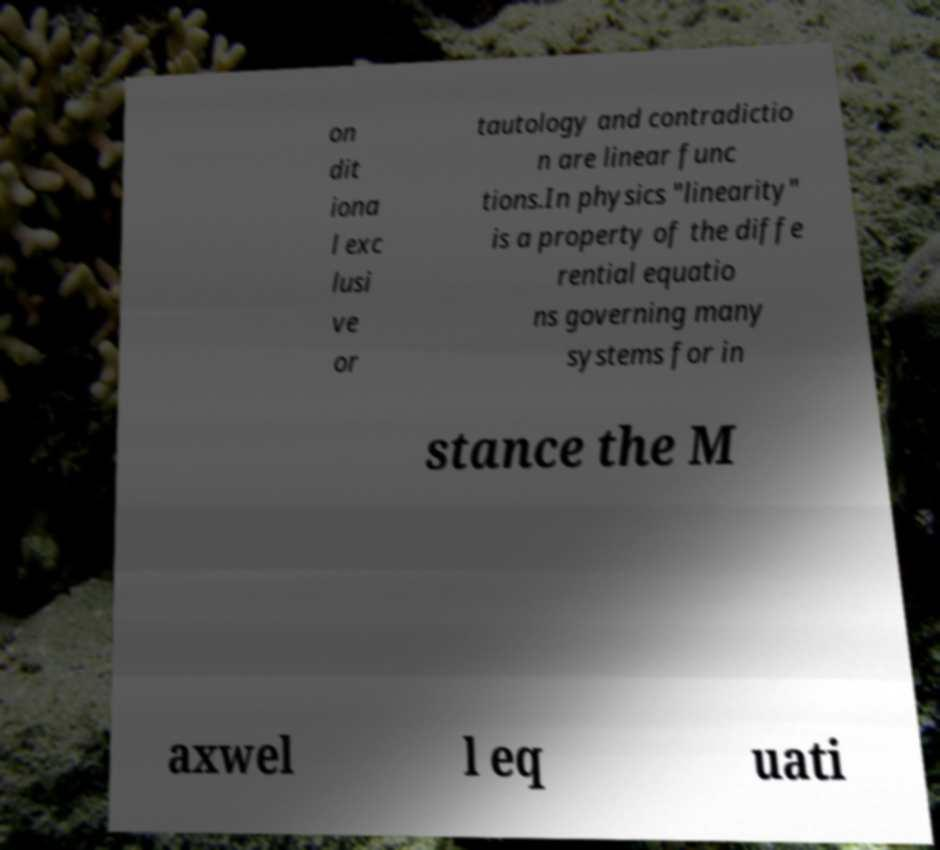Please read and relay the text visible in this image. What does it say? on dit iona l exc lusi ve or tautology and contradictio n are linear func tions.In physics "linearity" is a property of the diffe rential equatio ns governing many systems for in stance the M axwel l eq uati 